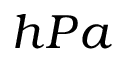<formula> <loc_0><loc_0><loc_500><loc_500>h P a</formula> 